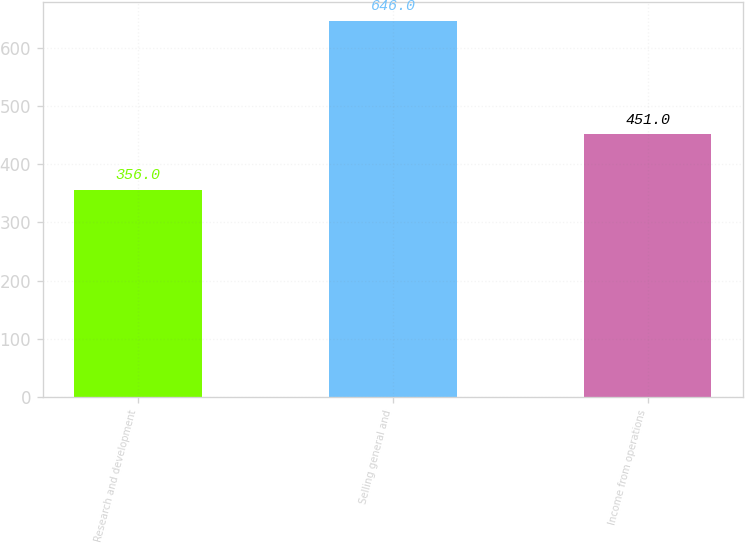Convert chart to OTSL. <chart><loc_0><loc_0><loc_500><loc_500><bar_chart><fcel>Research and development<fcel>Selling general and<fcel>Income from operations<nl><fcel>356<fcel>646<fcel>451<nl></chart> 